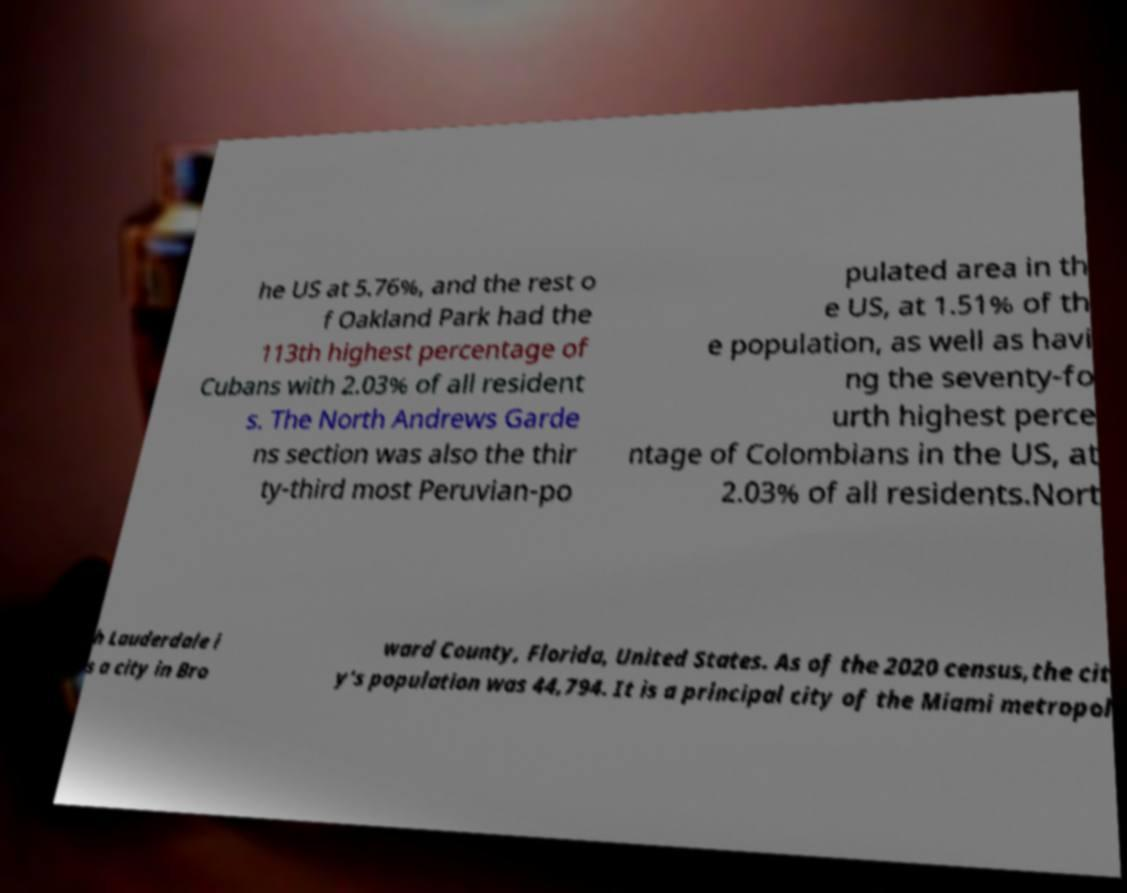There's text embedded in this image that I need extracted. Can you transcribe it verbatim? he US at 5.76%, and the rest o f Oakland Park had the 113th highest percentage of Cubans with 2.03% of all resident s. The North Andrews Garde ns section was also the thir ty-third most Peruvian-po pulated area in th e US, at 1.51% of th e population, as well as havi ng the seventy-fo urth highest perce ntage of Colombians in the US, at 2.03% of all residents.Nort h Lauderdale i s a city in Bro ward County, Florida, United States. As of the 2020 census,the cit y's population was 44,794. It is a principal city of the Miami metropol 